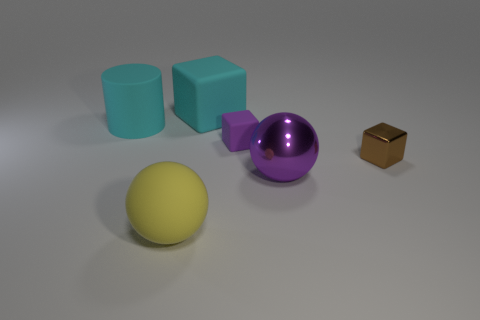Is the number of rubber balls that are behind the large purple metal sphere the same as the number of cyan matte things?
Offer a very short reply. No. Are there any other rubber cubes that have the same color as the big block?
Offer a very short reply. No. Does the purple ball have the same size as the metal cube?
Offer a very short reply. No. There is a cyan object behind the large object to the left of the big yellow object; how big is it?
Your response must be concise. Large. There is a thing that is behind the tiny purple matte thing and in front of the large cyan rubber block; what size is it?
Keep it short and to the point. Large. What number of purple objects have the same size as the brown cube?
Offer a terse response. 1. How many shiny things are either big cyan cubes or yellow spheres?
Ensure brevity in your answer.  0. What is the size of the metal sphere that is the same color as the tiny rubber cube?
Your answer should be very brief. Large. The purple thing that is in front of the small purple thing that is behind the purple ball is made of what material?
Give a very brief answer. Metal. How many things are cyan things or cubes to the left of the large purple metallic object?
Your answer should be compact. 3. 